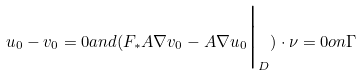<formula> <loc_0><loc_0><loc_500><loc_500>u _ { 0 } - v _ { 0 } = 0 a n d ( F _ { * } A \nabla v _ { 0 } - A \nabla u _ { 0 } \Big | _ { D } ) \cdot \nu = 0 o n \Gamma</formula> 